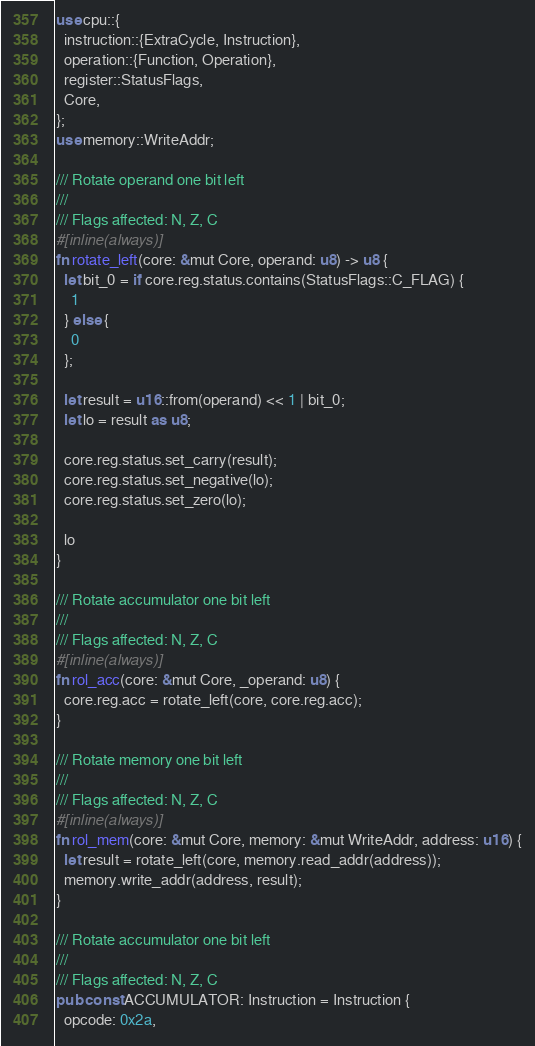<code> <loc_0><loc_0><loc_500><loc_500><_Rust_>use cpu::{
  instruction::{ExtraCycle, Instruction},
  operation::{Function, Operation},
  register::StatusFlags,
  Core,
};
use memory::WriteAddr;

/// Rotate operand one bit left
///
/// Flags affected: N, Z, C
#[inline(always)]
fn rotate_left(core: &mut Core, operand: u8) -> u8 {
  let bit_0 = if core.reg.status.contains(StatusFlags::C_FLAG) {
    1
  } else {
    0
  };

  let result = u16::from(operand) << 1 | bit_0;
  let lo = result as u8;

  core.reg.status.set_carry(result);
  core.reg.status.set_negative(lo);
  core.reg.status.set_zero(lo);

  lo
}

/// Rotate accumulator one bit left
///
/// Flags affected: N, Z, C
#[inline(always)]
fn rol_acc(core: &mut Core, _operand: u8) {
  core.reg.acc = rotate_left(core, core.reg.acc);
}

/// Rotate memory one bit left
///
/// Flags affected: N, Z, C
#[inline(always)]
fn rol_mem(core: &mut Core, memory: &mut WriteAddr, address: u16) {
  let result = rotate_left(core, memory.read_addr(address));
  memory.write_addr(address, result);
}

/// Rotate accumulator one bit left
///
/// Flags affected: N, Z, C
pub const ACCUMULATOR: Instruction = Instruction {
  opcode: 0x2a,</code> 